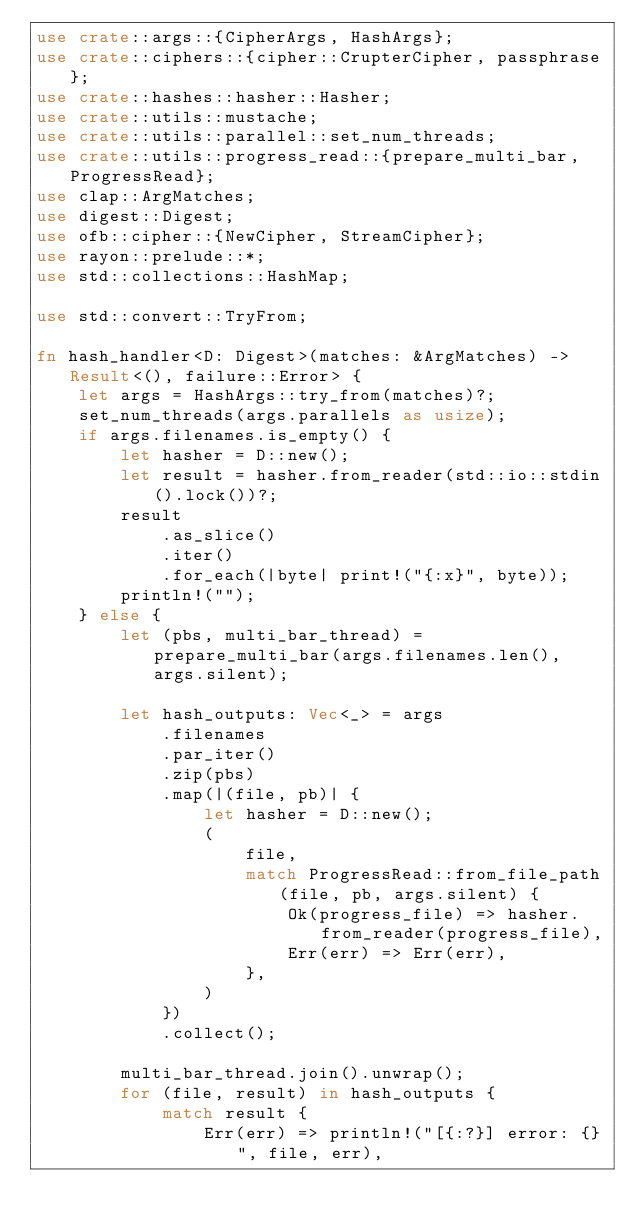<code> <loc_0><loc_0><loc_500><loc_500><_Rust_>use crate::args::{CipherArgs, HashArgs};
use crate::ciphers::{cipher::CrupterCipher, passphrase};
use crate::hashes::hasher::Hasher;
use crate::utils::mustache;
use crate::utils::parallel::set_num_threads;
use crate::utils::progress_read::{prepare_multi_bar, ProgressRead};
use clap::ArgMatches;
use digest::Digest;
use ofb::cipher::{NewCipher, StreamCipher};
use rayon::prelude::*;
use std::collections::HashMap;

use std::convert::TryFrom;

fn hash_handler<D: Digest>(matches: &ArgMatches) -> Result<(), failure::Error> {
    let args = HashArgs::try_from(matches)?;
    set_num_threads(args.parallels as usize);
    if args.filenames.is_empty() {
        let hasher = D::new();
        let result = hasher.from_reader(std::io::stdin().lock())?;
        result
            .as_slice()
            .iter()
            .for_each(|byte| print!("{:x}", byte));
        println!("");
    } else {
        let (pbs, multi_bar_thread) = prepare_multi_bar(args.filenames.len(), args.silent);

        let hash_outputs: Vec<_> = args
            .filenames
            .par_iter()
            .zip(pbs)
            .map(|(file, pb)| {
                let hasher = D::new();
                (
                    file,
                    match ProgressRead::from_file_path(file, pb, args.silent) {
                        Ok(progress_file) => hasher.from_reader(progress_file),
                        Err(err) => Err(err),
                    },
                )
            })
            .collect();

        multi_bar_thread.join().unwrap();
        for (file, result) in hash_outputs {
            match result {
                Err(err) => println!("[{:?}] error: {}", file, err),</code> 